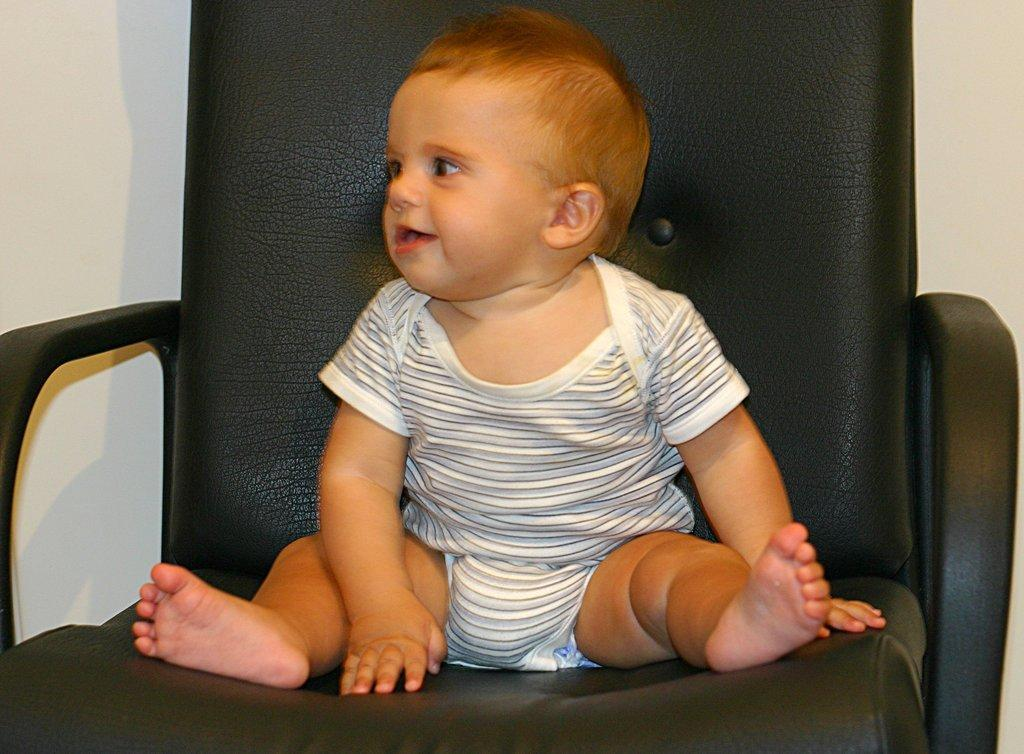What is the main subject of the image? There is a baby in the image. What is the baby sitting on? The baby is sitting on a black chair. How is the baby feeling in the image? The baby is smiling. What can be seen in the background of the image? There is a white wall in the background of the image. What type of toy is the baby shaking in the image? There is no toy present in the image, and the baby is not shaking anything. 